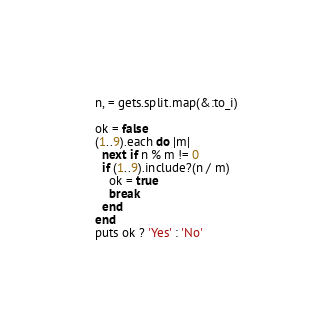<code> <loc_0><loc_0><loc_500><loc_500><_Ruby_>n, = gets.split.map(&:to_i)
 
ok = false
(1..9).each do |m|
  next if n % m != 0
  if (1..9).include?(n / m)
    ok = true
    break
  end
end
puts ok ? 'Yes' : 'No'</code> 